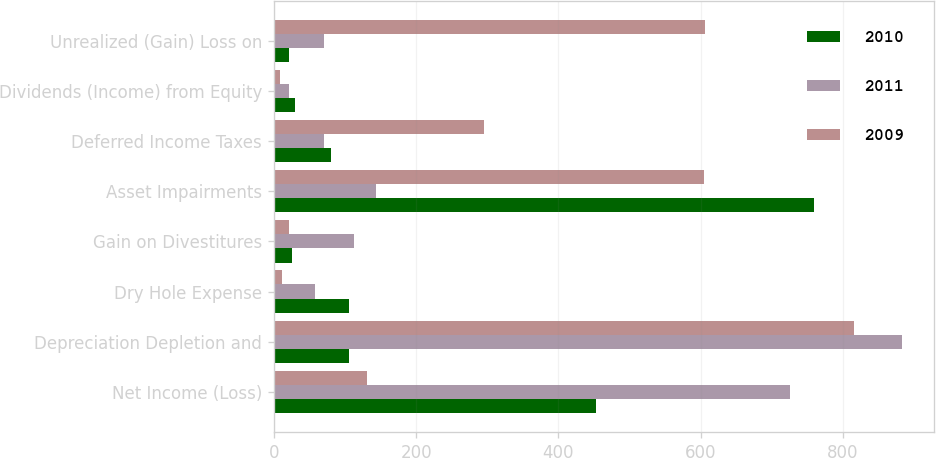Convert chart. <chart><loc_0><loc_0><loc_500><loc_500><stacked_bar_chart><ecel><fcel>Net Income (Loss)<fcel>Depreciation Depletion and<fcel>Dry Hole Expense<fcel>Gain on Divestitures<fcel>Asset Impairments<fcel>Deferred Income Taxes<fcel>Dividends (Income) from Equity<fcel>Unrealized (Gain) Loss on<nl><fcel>2010<fcel>453<fcel>105<fcel>105<fcel>25<fcel>759<fcel>81<fcel>30<fcel>22<nl><fcel>2011<fcel>725<fcel>883<fcel>58<fcel>113<fcel>144<fcel>71<fcel>21<fcel>70<nl><fcel>2009<fcel>131<fcel>816<fcel>11<fcel>22<fcel>604<fcel>296<fcel>8<fcel>606<nl></chart> 